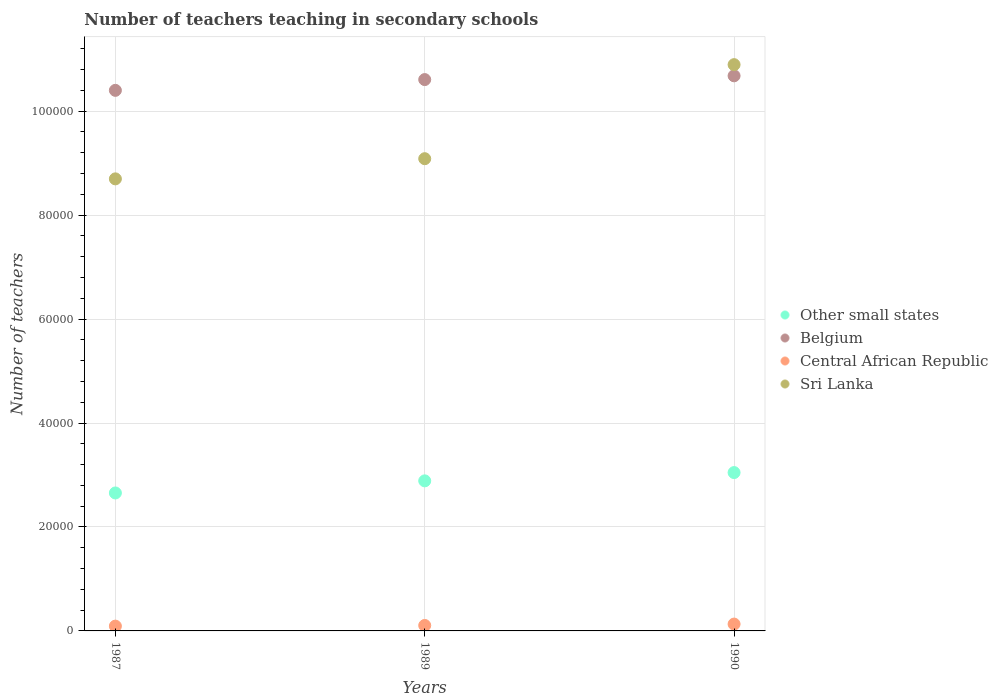How many different coloured dotlines are there?
Offer a terse response. 4. What is the number of teachers teaching in secondary schools in Sri Lanka in 1990?
Offer a terse response. 1.09e+05. Across all years, what is the maximum number of teachers teaching in secondary schools in Central African Republic?
Make the answer very short. 1317. Across all years, what is the minimum number of teachers teaching in secondary schools in Central African Republic?
Your response must be concise. 923. In which year was the number of teachers teaching in secondary schools in Other small states maximum?
Make the answer very short. 1990. What is the total number of teachers teaching in secondary schools in Central African Republic in the graph?
Give a very brief answer. 3292. What is the difference between the number of teachers teaching in secondary schools in Belgium in 1987 and that in 1990?
Keep it short and to the point. -2796. What is the difference between the number of teachers teaching in secondary schools in Belgium in 1989 and the number of teachers teaching in secondary schools in Sri Lanka in 1990?
Your response must be concise. -2873. What is the average number of teachers teaching in secondary schools in Sri Lanka per year?
Provide a short and direct response. 9.56e+04. In the year 1987, what is the difference between the number of teachers teaching in secondary schools in Sri Lanka and number of teachers teaching in secondary schools in Central African Republic?
Offer a terse response. 8.60e+04. In how many years, is the number of teachers teaching in secondary schools in Other small states greater than 100000?
Offer a very short reply. 0. What is the ratio of the number of teachers teaching in secondary schools in Other small states in 1987 to that in 1989?
Make the answer very short. 0.92. Is the difference between the number of teachers teaching in secondary schools in Sri Lanka in 1989 and 1990 greater than the difference between the number of teachers teaching in secondary schools in Central African Republic in 1989 and 1990?
Keep it short and to the point. No. What is the difference between the highest and the second highest number of teachers teaching in secondary schools in Sri Lanka?
Ensure brevity in your answer.  1.81e+04. What is the difference between the highest and the lowest number of teachers teaching in secondary schools in Central African Republic?
Keep it short and to the point. 394. Is it the case that in every year, the sum of the number of teachers teaching in secondary schools in Belgium and number of teachers teaching in secondary schools in Other small states  is greater than the sum of number of teachers teaching in secondary schools in Sri Lanka and number of teachers teaching in secondary schools in Central African Republic?
Ensure brevity in your answer.  Yes. How many dotlines are there?
Provide a short and direct response. 4. Are the values on the major ticks of Y-axis written in scientific E-notation?
Keep it short and to the point. No. Does the graph contain any zero values?
Give a very brief answer. No. Does the graph contain grids?
Offer a terse response. Yes. What is the title of the graph?
Give a very brief answer. Number of teachers teaching in secondary schools. What is the label or title of the Y-axis?
Give a very brief answer. Number of teachers. What is the Number of teachers in Other small states in 1987?
Offer a very short reply. 2.65e+04. What is the Number of teachers in Belgium in 1987?
Provide a short and direct response. 1.04e+05. What is the Number of teachers of Central African Republic in 1987?
Your response must be concise. 923. What is the Number of teachers of Sri Lanka in 1987?
Offer a terse response. 8.70e+04. What is the Number of teachers in Other small states in 1989?
Provide a succinct answer. 2.89e+04. What is the Number of teachers in Belgium in 1989?
Offer a very short reply. 1.06e+05. What is the Number of teachers of Central African Republic in 1989?
Your response must be concise. 1052. What is the Number of teachers of Sri Lanka in 1989?
Your answer should be compact. 9.09e+04. What is the Number of teachers of Other small states in 1990?
Your answer should be very brief. 3.05e+04. What is the Number of teachers of Belgium in 1990?
Make the answer very short. 1.07e+05. What is the Number of teachers in Central African Republic in 1990?
Your answer should be very brief. 1317. What is the Number of teachers of Sri Lanka in 1990?
Provide a succinct answer. 1.09e+05. Across all years, what is the maximum Number of teachers of Other small states?
Offer a terse response. 3.05e+04. Across all years, what is the maximum Number of teachers of Belgium?
Offer a very short reply. 1.07e+05. Across all years, what is the maximum Number of teachers in Central African Republic?
Ensure brevity in your answer.  1317. Across all years, what is the maximum Number of teachers in Sri Lanka?
Provide a short and direct response. 1.09e+05. Across all years, what is the minimum Number of teachers in Other small states?
Make the answer very short. 2.65e+04. Across all years, what is the minimum Number of teachers of Belgium?
Keep it short and to the point. 1.04e+05. Across all years, what is the minimum Number of teachers in Central African Republic?
Provide a short and direct response. 923. Across all years, what is the minimum Number of teachers of Sri Lanka?
Your answer should be very brief. 8.70e+04. What is the total Number of teachers of Other small states in the graph?
Your answer should be compact. 8.59e+04. What is the total Number of teachers of Belgium in the graph?
Provide a short and direct response. 3.17e+05. What is the total Number of teachers in Central African Republic in the graph?
Keep it short and to the point. 3292. What is the total Number of teachers in Sri Lanka in the graph?
Give a very brief answer. 2.87e+05. What is the difference between the Number of teachers of Other small states in 1987 and that in 1989?
Provide a short and direct response. -2327.93. What is the difference between the Number of teachers of Belgium in 1987 and that in 1989?
Make the answer very short. -2072. What is the difference between the Number of teachers in Central African Republic in 1987 and that in 1989?
Ensure brevity in your answer.  -129. What is the difference between the Number of teachers in Sri Lanka in 1987 and that in 1989?
Offer a terse response. -3881. What is the difference between the Number of teachers in Other small states in 1987 and that in 1990?
Ensure brevity in your answer.  -3921.27. What is the difference between the Number of teachers in Belgium in 1987 and that in 1990?
Your answer should be compact. -2796. What is the difference between the Number of teachers in Central African Republic in 1987 and that in 1990?
Your response must be concise. -394. What is the difference between the Number of teachers of Sri Lanka in 1987 and that in 1990?
Offer a very short reply. -2.20e+04. What is the difference between the Number of teachers in Other small states in 1989 and that in 1990?
Your response must be concise. -1593.34. What is the difference between the Number of teachers of Belgium in 1989 and that in 1990?
Offer a very short reply. -724. What is the difference between the Number of teachers in Central African Republic in 1989 and that in 1990?
Provide a short and direct response. -265. What is the difference between the Number of teachers of Sri Lanka in 1989 and that in 1990?
Make the answer very short. -1.81e+04. What is the difference between the Number of teachers in Other small states in 1987 and the Number of teachers in Belgium in 1989?
Provide a short and direct response. -7.95e+04. What is the difference between the Number of teachers of Other small states in 1987 and the Number of teachers of Central African Republic in 1989?
Ensure brevity in your answer.  2.55e+04. What is the difference between the Number of teachers in Other small states in 1987 and the Number of teachers in Sri Lanka in 1989?
Your answer should be very brief. -6.43e+04. What is the difference between the Number of teachers in Belgium in 1987 and the Number of teachers in Central African Republic in 1989?
Your answer should be very brief. 1.03e+05. What is the difference between the Number of teachers of Belgium in 1987 and the Number of teachers of Sri Lanka in 1989?
Your answer should be very brief. 1.31e+04. What is the difference between the Number of teachers in Central African Republic in 1987 and the Number of teachers in Sri Lanka in 1989?
Provide a short and direct response. -8.99e+04. What is the difference between the Number of teachers of Other small states in 1987 and the Number of teachers of Belgium in 1990?
Your response must be concise. -8.03e+04. What is the difference between the Number of teachers in Other small states in 1987 and the Number of teachers in Central African Republic in 1990?
Keep it short and to the point. 2.52e+04. What is the difference between the Number of teachers in Other small states in 1987 and the Number of teachers in Sri Lanka in 1990?
Your answer should be compact. -8.24e+04. What is the difference between the Number of teachers of Belgium in 1987 and the Number of teachers of Central African Republic in 1990?
Ensure brevity in your answer.  1.03e+05. What is the difference between the Number of teachers in Belgium in 1987 and the Number of teachers in Sri Lanka in 1990?
Ensure brevity in your answer.  -4945. What is the difference between the Number of teachers of Central African Republic in 1987 and the Number of teachers of Sri Lanka in 1990?
Ensure brevity in your answer.  -1.08e+05. What is the difference between the Number of teachers in Other small states in 1989 and the Number of teachers in Belgium in 1990?
Give a very brief answer. -7.79e+04. What is the difference between the Number of teachers in Other small states in 1989 and the Number of teachers in Central African Republic in 1990?
Provide a succinct answer. 2.76e+04. What is the difference between the Number of teachers of Other small states in 1989 and the Number of teachers of Sri Lanka in 1990?
Offer a terse response. -8.01e+04. What is the difference between the Number of teachers of Belgium in 1989 and the Number of teachers of Central African Republic in 1990?
Provide a succinct answer. 1.05e+05. What is the difference between the Number of teachers in Belgium in 1989 and the Number of teachers in Sri Lanka in 1990?
Your response must be concise. -2873. What is the difference between the Number of teachers of Central African Republic in 1989 and the Number of teachers of Sri Lanka in 1990?
Your answer should be very brief. -1.08e+05. What is the average Number of teachers in Other small states per year?
Your answer should be very brief. 2.86e+04. What is the average Number of teachers of Belgium per year?
Ensure brevity in your answer.  1.06e+05. What is the average Number of teachers in Central African Republic per year?
Your answer should be compact. 1097.33. What is the average Number of teachers in Sri Lanka per year?
Offer a terse response. 9.56e+04. In the year 1987, what is the difference between the Number of teachers in Other small states and Number of teachers in Belgium?
Your answer should be compact. -7.75e+04. In the year 1987, what is the difference between the Number of teachers in Other small states and Number of teachers in Central African Republic?
Ensure brevity in your answer.  2.56e+04. In the year 1987, what is the difference between the Number of teachers of Other small states and Number of teachers of Sri Lanka?
Keep it short and to the point. -6.04e+04. In the year 1987, what is the difference between the Number of teachers in Belgium and Number of teachers in Central African Republic?
Keep it short and to the point. 1.03e+05. In the year 1987, what is the difference between the Number of teachers in Belgium and Number of teachers in Sri Lanka?
Give a very brief answer. 1.70e+04. In the year 1987, what is the difference between the Number of teachers in Central African Republic and Number of teachers in Sri Lanka?
Provide a short and direct response. -8.60e+04. In the year 1989, what is the difference between the Number of teachers in Other small states and Number of teachers in Belgium?
Offer a very short reply. -7.72e+04. In the year 1989, what is the difference between the Number of teachers of Other small states and Number of teachers of Central African Republic?
Ensure brevity in your answer.  2.78e+04. In the year 1989, what is the difference between the Number of teachers of Other small states and Number of teachers of Sri Lanka?
Keep it short and to the point. -6.20e+04. In the year 1989, what is the difference between the Number of teachers in Belgium and Number of teachers in Central African Republic?
Your response must be concise. 1.05e+05. In the year 1989, what is the difference between the Number of teachers in Belgium and Number of teachers in Sri Lanka?
Your answer should be compact. 1.52e+04. In the year 1989, what is the difference between the Number of teachers in Central African Republic and Number of teachers in Sri Lanka?
Offer a very short reply. -8.98e+04. In the year 1990, what is the difference between the Number of teachers of Other small states and Number of teachers of Belgium?
Offer a terse response. -7.63e+04. In the year 1990, what is the difference between the Number of teachers in Other small states and Number of teachers in Central African Republic?
Keep it short and to the point. 2.91e+04. In the year 1990, what is the difference between the Number of teachers of Other small states and Number of teachers of Sri Lanka?
Ensure brevity in your answer.  -7.85e+04. In the year 1990, what is the difference between the Number of teachers in Belgium and Number of teachers in Central African Republic?
Ensure brevity in your answer.  1.05e+05. In the year 1990, what is the difference between the Number of teachers of Belgium and Number of teachers of Sri Lanka?
Provide a short and direct response. -2149. In the year 1990, what is the difference between the Number of teachers in Central African Republic and Number of teachers in Sri Lanka?
Provide a short and direct response. -1.08e+05. What is the ratio of the Number of teachers in Other small states in 1987 to that in 1989?
Keep it short and to the point. 0.92. What is the ratio of the Number of teachers in Belgium in 1987 to that in 1989?
Offer a very short reply. 0.98. What is the ratio of the Number of teachers in Central African Republic in 1987 to that in 1989?
Keep it short and to the point. 0.88. What is the ratio of the Number of teachers in Sri Lanka in 1987 to that in 1989?
Offer a terse response. 0.96. What is the ratio of the Number of teachers in Other small states in 1987 to that in 1990?
Your response must be concise. 0.87. What is the ratio of the Number of teachers in Belgium in 1987 to that in 1990?
Keep it short and to the point. 0.97. What is the ratio of the Number of teachers in Central African Republic in 1987 to that in 1990?
Give a very brief answer. 0.7. What is the ratio of the Number of teachers of Sri Lanka in 1987 to that in 1990?
Give a very brief answer. 0.8. What is the ratio of the Number of teachers of Other small states in 1989 to that in 1990?
Make the answer very short. 0.95. What is the ratio of the Number of teachers of Central African Republic in 1989 to that in 1990?
Your answer should be very brief. 0.8. What is the ratio of the Number of teachers of Sri Lanka in 1989 to that in 1990?
Make the answer very short. 0.83. What is the difference between the highest and the second highest Number of teachers in Other small states?
Offer a very short reply. 1593.34. What is the difference between the highest and the second highest Number of teachers in Belgium?
Your answer should be very brief. 724. What is the difference between the highest and the second highest Number of teachers of Central African Republic?
Provide a short and direct response. 265. What is the difference between the highest and the second highest Number of teachers in Sri Lanka?
Offer a very short reply. 1.81e+04. What is the difference between the highest and the lowest Number of teachers of Other small states?
Offer a very short reply. 3921.27. What is the difference between the highest and the lowest Number of teachers in Belgium?
Your answer should be very brief. 2796. What is the difference between the highest and the lowest Number of teachers of Central African Republic?
Keep it short and to the point. 394. What is the difference between the highest and the lowest Number of teachers of Sri Lanka?
Make the answer very short. 2.20e+04. 